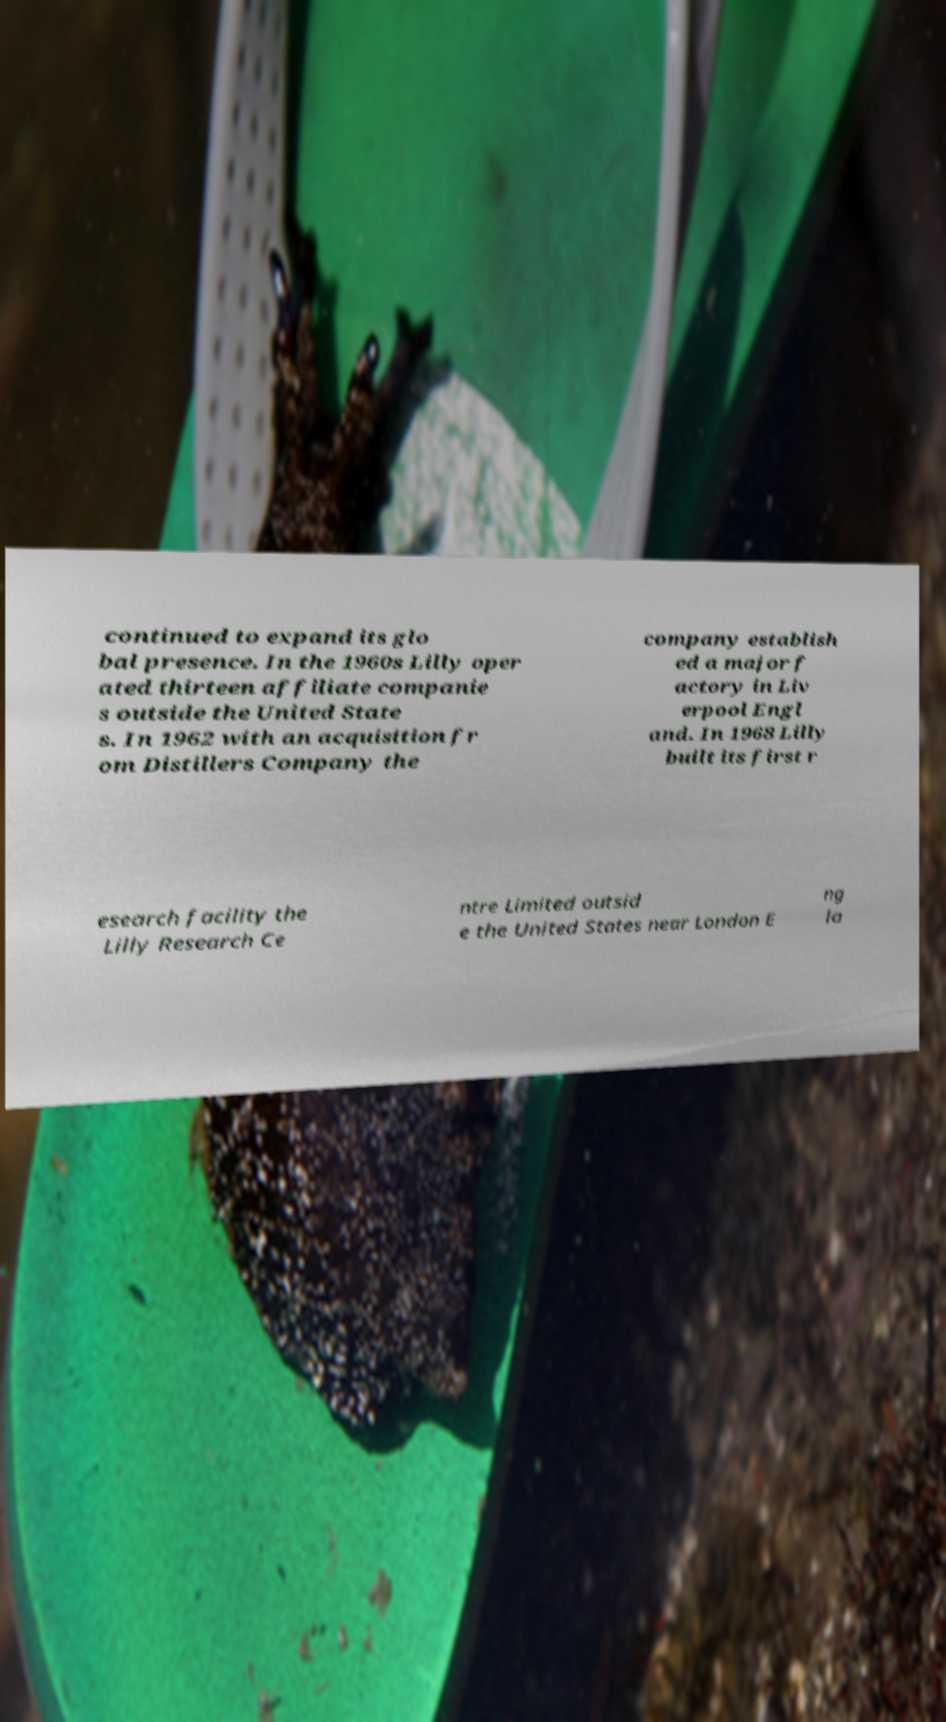What messages or text are displayed in this image? I need them in a readable, typed format. continued to expand its glo bal presence. In the 1960s Lilly oper ated thirteen affiliate companie s outside the United State s. In 1962 with an acquisition fr om Distillers Company the company establish ed a major f actory in Liv erpool Engl and. In 1968 Lilly built its first r esearch facility the Lilly Research Ce ntre Limited outsid e the United States near London E ng la 